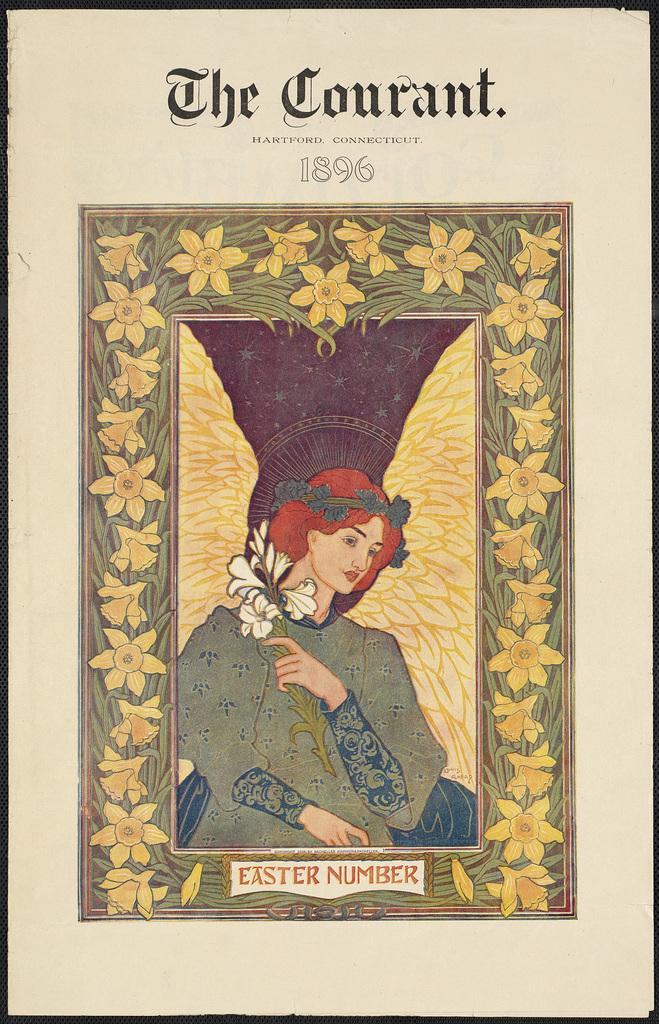What is the main object in the image? There is a frame in the image. What is depicted inside the frame? The frame contains a lady. What is the lady holding in her hand? The lady is holding flowers in her hand. Are there any flowers outside the frame? Yes, there are flowers around the frame. What else can be seen in the image besides the lady and flowers? There is some text in the image. How many teeth can be seen in the lady's smile in the image? There is no lady smiling in the image, and therefore no teeth are visible. 